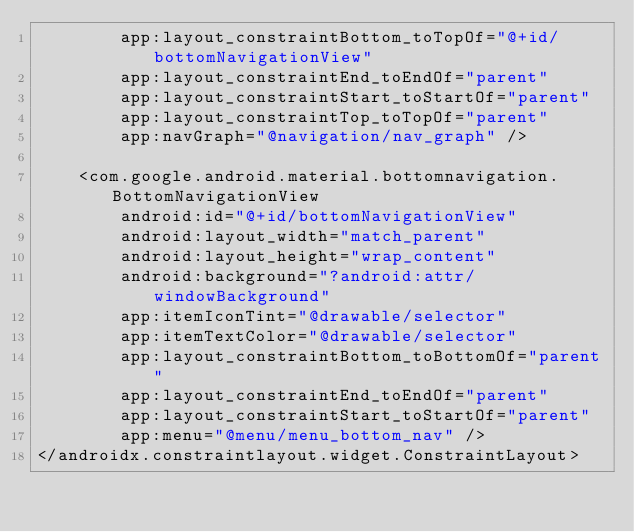<code> <loc_0><loc_0><loc_500><loc_500><_XML_>        app:layout_constraintBottom_toTopOf="@+id/bottomNavigationView"
        app:layout_constraintEnd_toEndOf="parent"
        app:layout_constraintStart_toStartOf="parent"
        app:layout_constraintTop_toTopOf="parent"
        app:navGraph="@navigation/nav_graph" />

    <com.google.android.material.bottomnavigation.BottomNavigationView
        android:id="@+id/bottomNavigationView"
        android:layout_width="match_parent"
        android:layout_height="wrap_content"
        android:background="?android:attr/windowBackground"
        app:itemIconTint="@drawable/selector"
        app:itemTextColor="@drawable/selector"
        app:layout_constraintBottom_toBottomOf="parent"
        app:layout_constraintEnd_toEndOf="parent"
        app:layout_constraintStart_toStartOf="parent"
        app:menu="@menu/menu_bottom_nav" />
</androidx.constraintlayout.widget.ConstraintLayout></code> 